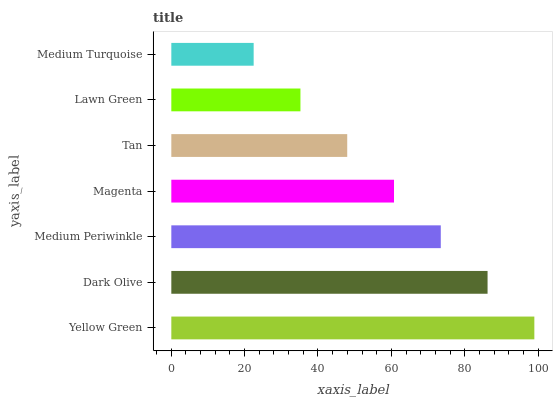Is Medium Turquoise the minimum?
Answer yes or no. Yes. Is Yellow Green the maximum?
Answer yes or no. Yes. Is Dark Olive the minimum?
Answer yes or no. No. Is Dark Olive the maximum?
Answer yes or no. No. Is Yellow Green greater than Dark Olive?
Answer yes or no. Yes. Is Dark Olive less than Yellow Green?
Answer yes or no. Yes. Is Dark Olive greater than Yellow Green?
Answer yes or no. No. Is Yellow Green less than Dark Olive?
Answer yes or no. No. Is Magenta the high median?
Answer yes or no. Yes. Is Magenta the low median?
Answer yes or no. Yes. Is Dark Olive the high median?
Answer yes or no. No. Is Yellow Green the low median?
Answer yes or no. No. 